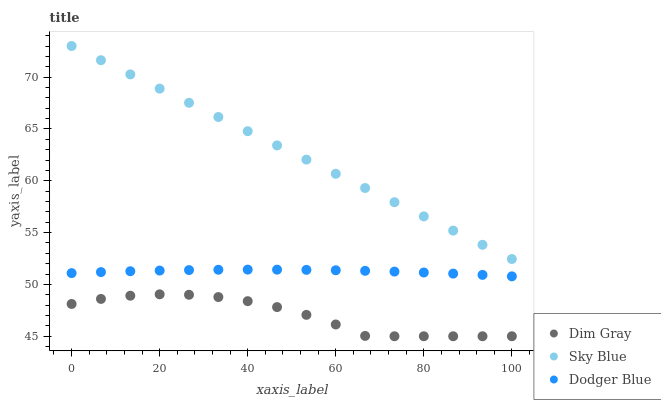Does Dim Gray have the minimum area under the curve?
Answer yes or no. Yes. Does Sky Blue have the maximum area under the curve?
Answer yes or no. Yes. Does Dodger Blue have the minimum area under the curve?
Answer yes or no. No. Does Dodger Blue have the maximum area under the curve?
Answer yes or no. No. Is Sky Blue the smoothest?
Answer yes or no. Yes. Is Dim Gray the roughest?
Answer yes or no. Yes. Is Dodger Blue the smoothest?
Answer yes or no. No. Is Dodger Blue the roughest?
Answer yes or no. No. Does Dim Gray have the lowest value?
Answer yes or no. Yes. Does Dodger Blue have the lowest value?
Answer yes or no. No. Does Sky Blue have the highest value?
Answer yes or no. Yes. Does Dodger Blue have the highest value?
Answer yes or no. No. Is Dim Gray less than Dodger Blue?
Answer yes or no. Yes. Is Sky Blue greater than Dim Gray?
Answer yes or no. Yes. Does Dim Gray intersect Dodger Blue?
Answer yes or no. No. 